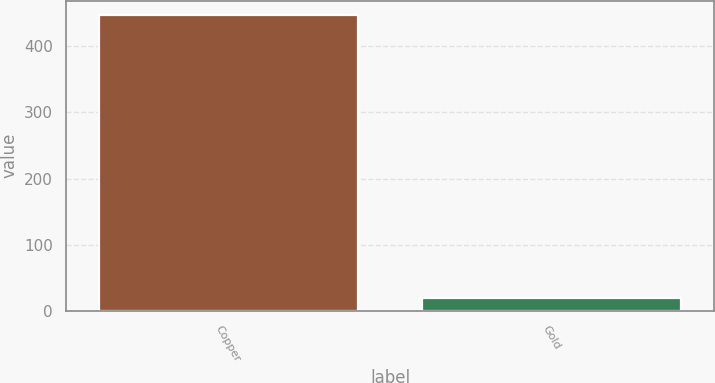Convert chart. <chart><loc_0><loc_0><loc_500><loc_500><bar_chart><fcel>Copper<fcel>Gold<nl><fcel>447<fcel>19<nl></chart> 